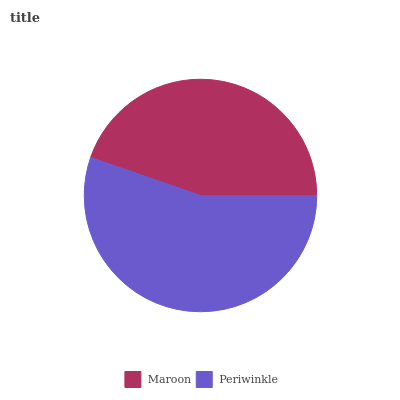Is Maroon the minimum?
Answer yes or no. Yes. Is Periwinkle the maximum?
Answer yes or no. Yes. Is Periwinkle the minimum?
Answer yes or no. No. Is Periwinkle greater than Maroon?
Answer yes or no. Yes. Is Maroon less than Periwinkle?
Answer yes or no. Yes. Is Maroon greater than Periwinkle?
Answer yes or no. No. Is Periwinkle less than Maroon?
Answer yes or no. No. Is Periwinkle the high median?
Answer yes or no. Yes. Is Maroon the low median?
Answer yes or no. Yes. Is Maroon the high median?
Answer yes or no. No. Is Periwinkle the low median?
Answer yes or no. No. 